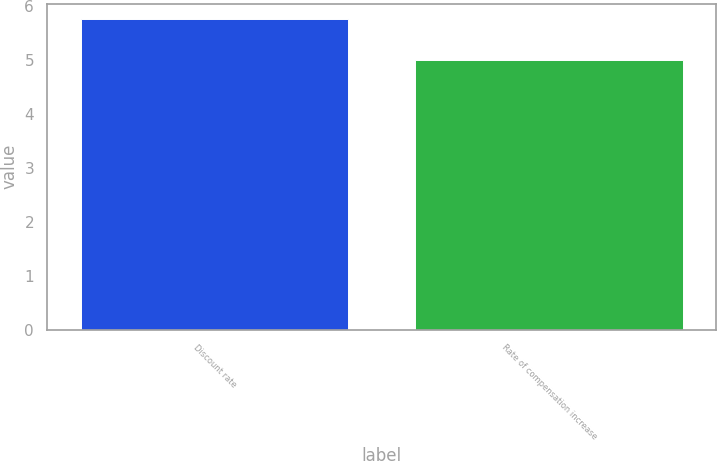<chart> <loc_0><loc_0><loc_500><loc_500><bar_chart><fcel>Discount rate<fcel>Rate of compensation increase<nl><fcel>5.75<fcel>5<nl></chart> 